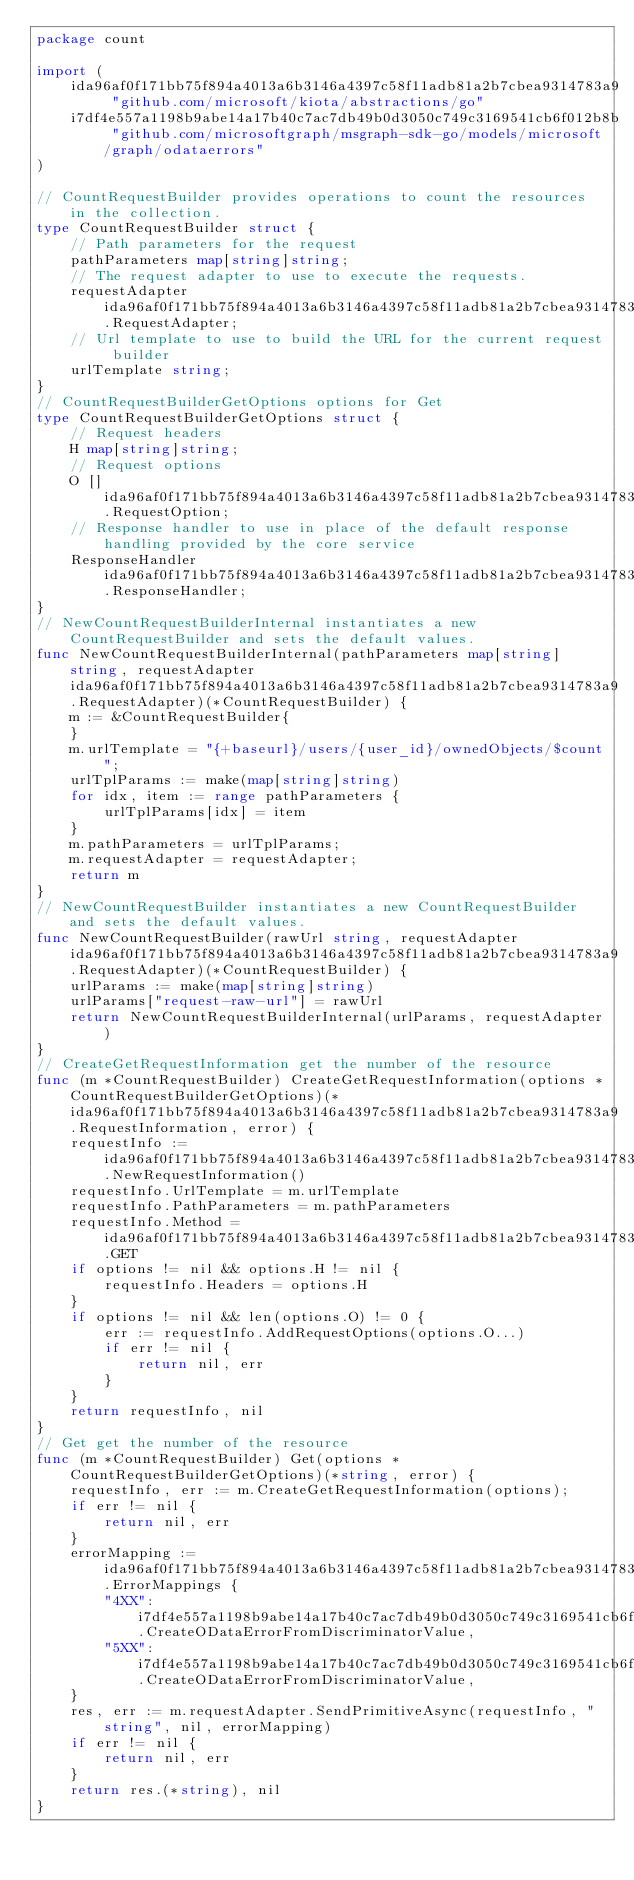<code> <loc_0><loc_0><loc_500><loc_500><_Go_>package count

import (
    ida96af0f171bb75f894a4013a6b3146a4397c58f11adb81a2b7cbea9314783a9 "github.com/microsoft/kiota/abstractions/go"
    i7df4e557a1198b9abe14a17b40c7ac7db49b0d3050c749c3169541cb6f012b8b "github.com/microsoftgraph/msgraph-sdk-go/models/microsoft/graph/odataerrors"
)

// CountRequestBuilder provides operations to count the resources in the collection.
type CountRequestBuilder struct {
    // Path parameters for the request
    pathParameters map[string]string;
    // The request adapter to use to execute the requests.
    requestAdapter ida96af0f171bb75f894a4013a6b3146a4397c58f11adb81a2b7cbea9314783a9.RequestAdapter;
    // Url template to use to build the URL for the current request builder
    urlTemplate string;
}
// CountRequestBuilderGetOptions options for Get
type CountRequestBuilderGetOptions struct {
    // Request headers
    H map[string]string;
    // Request options
    O []ida96af0f171bb75f894a4013a6b3146a4397c58f11adb81a2b7cbea9314783a9.RequestOption;
    // Response handler to use in place of the default response handling provided by the core service
    ResponseHandler ida96af0f171bb75f894a4013a6b3146a4397c58f11adb81a2b7cbea9314783a9.ResponseHandler;
}
// NewCountRequestBuilderInternal instantiates a new CountRequestBuilder and sets the default values.
func NewCountRequestBuilderInternal(pathParameters map[string]string, requestAdapter ida96af0f171bb75f894a4013a6b3146a4397c58f11adb81a2b7cbea9314783a9.RequestAdapter)(*CountRequestBuilder) {
    m := &CountRequestBuilder{
    }
    m.urlTemplate = "{+baseurl}/users/{user_id}/ownedObjects/$count";
    urlTplParams := make(map[string]string)
    for idx, item := range pathParameters {
        urlTplParams[idx] = item
    }
    m.pathParameters = urlTplParams;
    m.requestAdapter = requestAdapter;
    return m
}
// NewCountRequestBuilder instantiates a new CountRequestBuilder and sets the default values.
func NewCountRequestBuilder(rawUrl string, requestAdapter ida96af0f171bb75f894a4013a6b3146a4397c58f11adb81a2b7cbea9314783a9.RequestAdapter)(*CountRequestBuilder) {
    urlParams := make(map[string]string)
    urlParams["request-raw-url"] = rawUrl
    return NewCountRequestBuilderInternal(urlParams, requestAdapter)
}
// CreateGetRequestInformation get the number of the resource
func (m *CountRequestBuilder) CreateGetRequestInformation(options *CountRequestBuilderGetOptions)(*ida96af0f171bb75f894a4013a6b3146a4397c58f11adb81a2b7cbea9314783a9.RequestInformation, error) {
    requestInfo := ida96af0f171bb75f894a4013a6b3146a4397c58f11adb81a2b7cbea9314783a9.NewRequestInformation()
    requestInfo.UrlTemplate = m.urlTemplate
    requestInfo.PathParameters = m.pathParameters
    requestInfo.Method = ida96af0f171bb75f894a4013a6b3146a4397c58f11adb81a2b7cbea9314783a9.GET
    if options != nil && options.H != nil {
        requestInfo.Headers = options.H
    }
    if options != nil && len(options.O) != 0 {
        err := requestInfo.AddRequestOptions(options.O...)
        if err != nil {
            return nil, err
        }
    }
    return requestInfo, nil
}
// Get get the number of the resource
func (m *CountRequestBuilder) Get(options *CountRequestBuilderGetOptions)(*string, error) {
    requestInfo, err := m.CreateGetRequestInformation(options);
    if err != nil {
        return nil, err
    }
    errorMapping := ida96af0f171bb75f894a4013a6b3146a4397c58f11adb81a2b7cbea9314783a9.ErrorMappings {
        "4XX": i7df4e557a1198b9abe14a17b40c7ac7db49b0d3050c749c3169541cb6f012b8b.CreateODataErrorFromDiscriminatorValue,
        "5XX": i7df4e557a1198b9abe14a17b40c7ac7db49b0d3050c749c3169541cb6f012b8b.CreateODataErrorFromDiscriminatorValue,
    }
    res, err := m.requestAdapter.SendPrimitiveAsync(requestInfo, "string", nil, errorMapping)
    if err != nil {
        return nil, err
    }
    return res.(*string), nil
}
</code> 